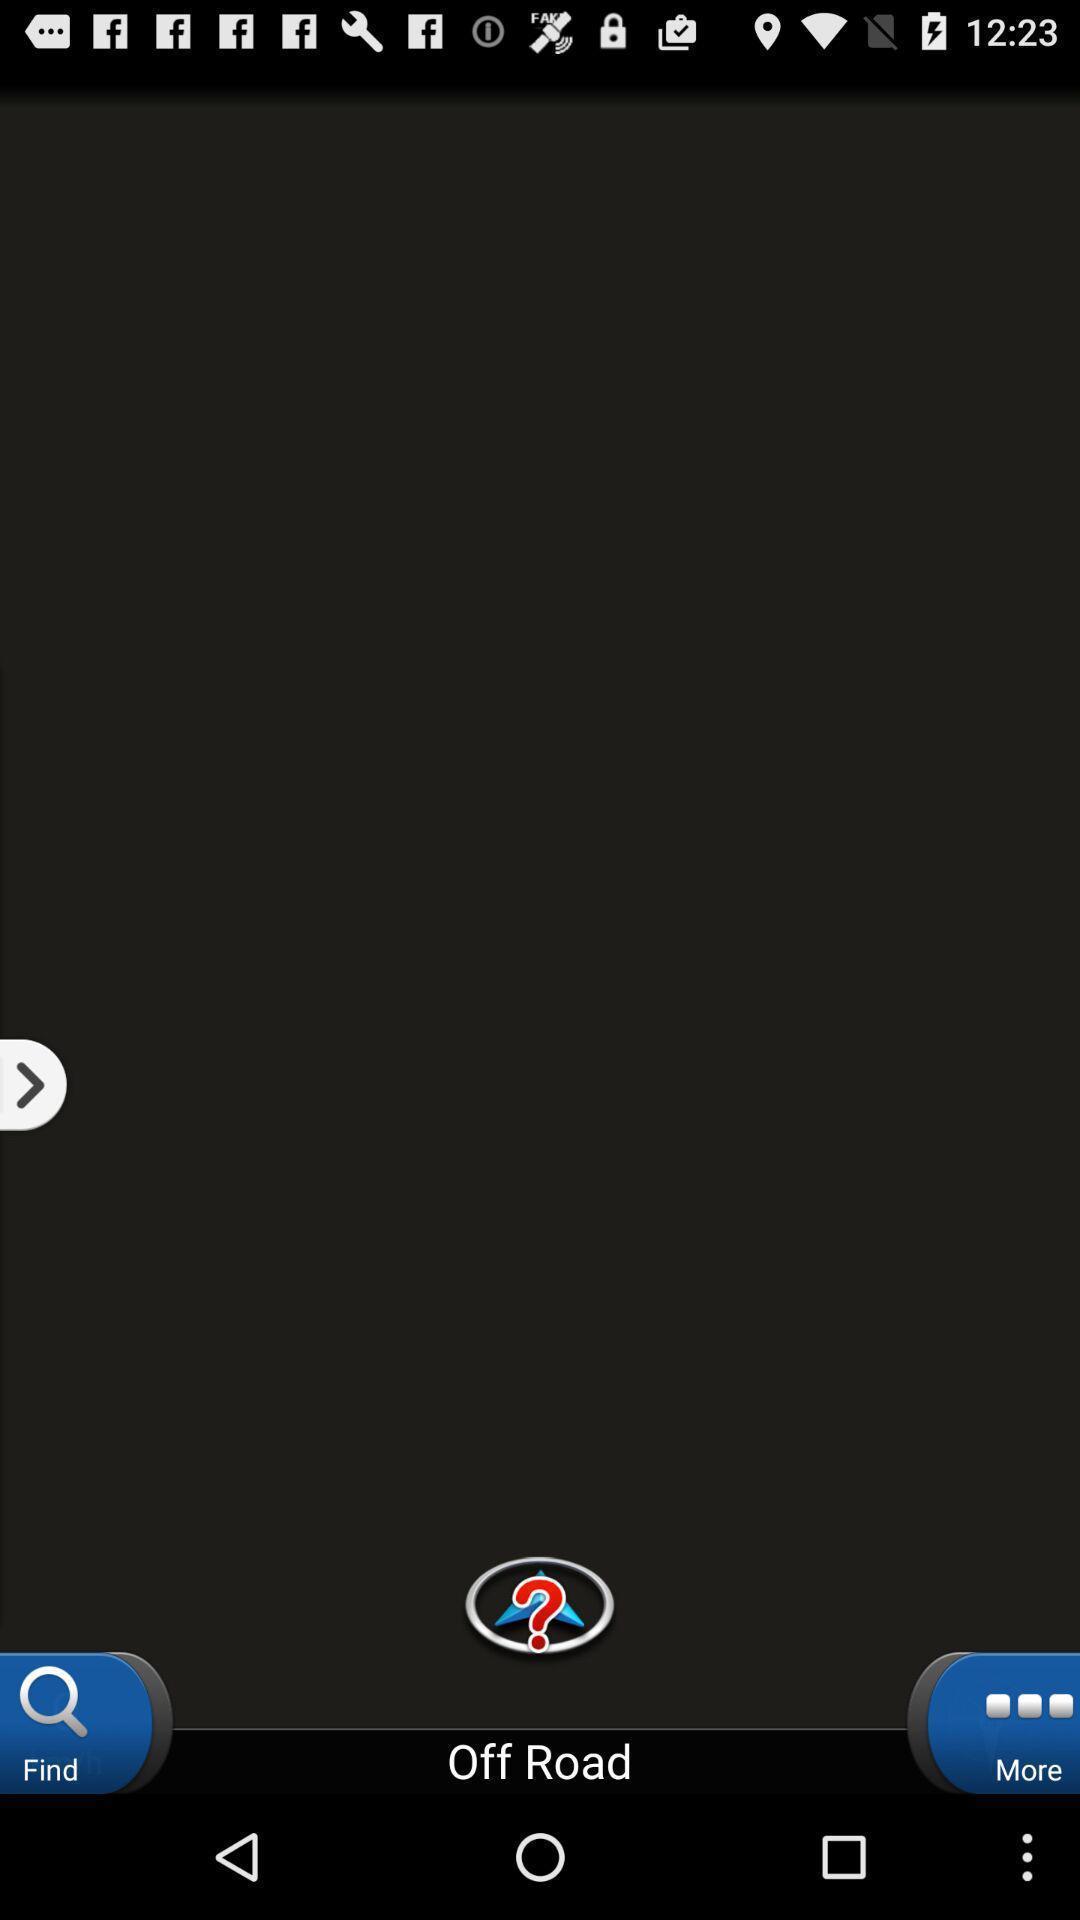Provide a textual representation of this image. Page displaying more options. 